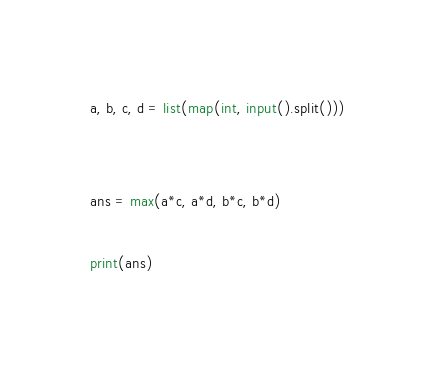<code> <loc_0><loc_0><loc_500><loc_500><_Python_>a, b, c, d = list(map(int, input().split()))


ans = max(a*c, a*d, b*c, b*d)

print(ans)</code> 